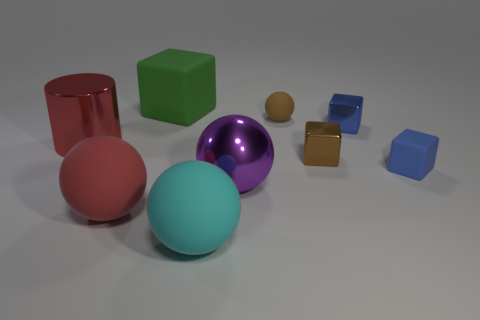Add 1 small objects. How many objects exist? 10 Subtract all spheres. How many objects are left? 5 Subtract 3 cubes. How many cubes are left? 1 Subtract all tiny matte spheres. How many spheres are left? 3 Subtract all brown blocks. How many red balls are left? 1 Subtract all tiny yellow things. Subtract all matte cubes. How many objects are left? 7 Add 9 green objects. How many green objects are left? 10 Add 4 cyan rubber cylinders. How many cyan rubber cylinders exist? 4 Subtract all green blocks. How many blocks are left? 3 Subtract 0 yellow cylinders. How many objects are left? 9 